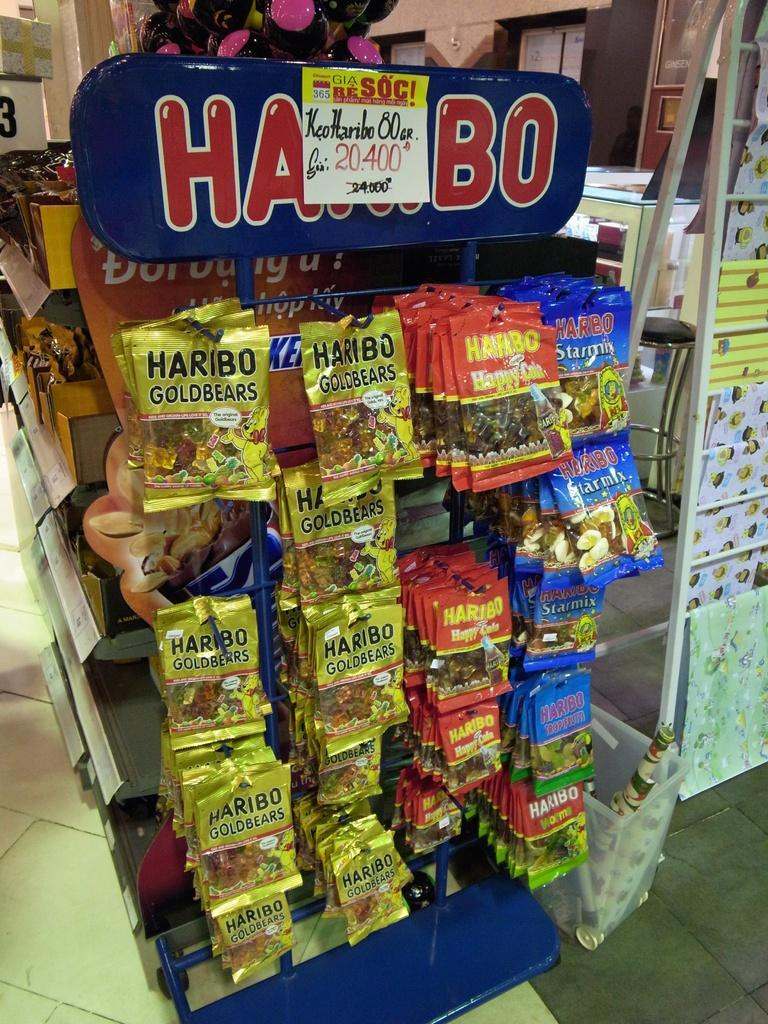<image>
Present a compact description of the photo's key features. A display showing many packs of Haribo Goldbears 